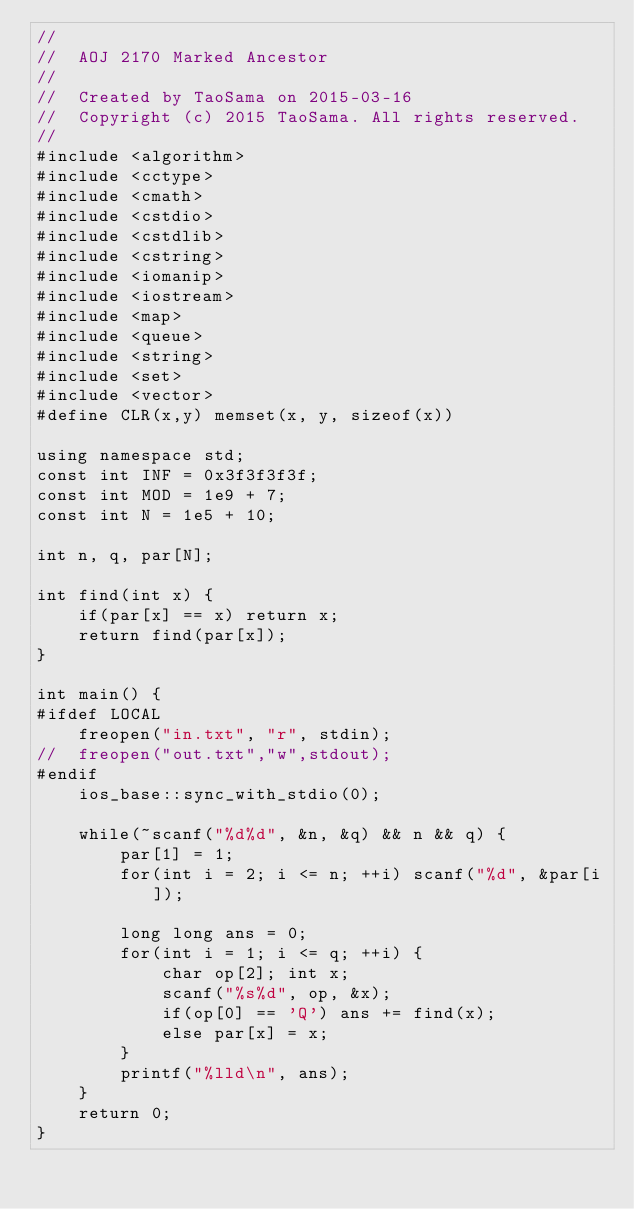Convert code to text. <code><loc_0><loc_0><loc_500><loc_500><_C++_>//
//  AOJ 2170 Marked Ancestor
//
//  Created by TaoSama on 2015-03-16
//  Copyright (c) 2015 TaoSama. All rights reserved.
//
#include <algorithm>
#include <cctype>
#include <cmath>
#include <cstdio>
#include <cstdlib>
#include <cstring>
#include <iomanip>
#include <iostream>
#include <map>
#include <queue>
#include <string>
#include <set>
#include <vector>
#define CLR(x,y) memset(x, y, sizeof(x))

using namespace std;
const int INF = 0x3f3f3f3f;
const int MOD = 1e9 + 7;
const int N = 1e5 + 10;

int n, q, par[N];

int find(int x) {
	if(par[x] == x) return x;
	return find(par[x]);
}

int main() {
#ifdef LOCAL
	freopen("in.txt", "r", stdin);
//	freopen("out.txt","w",stdout);
#endif
	ios_base::sync_with_stdio(0);

	while(~scanf("%d%d", &n, &q) && n && q) {
		par[1] = 1;
		for(int i = 2; i <= n; ++i) scanf("%d", &par[i]);

		long long ans = 0;
		for(int i = 1; i <= q; ++i) {
			char op[2]; int x;
			scanf("%s%d", op, &x);
			if(op[0] == 'Q') ans += find(x);
			else par[x] = x;
		}
		printf("%lld\n", ans);
	}
	return 0;
}</code> 